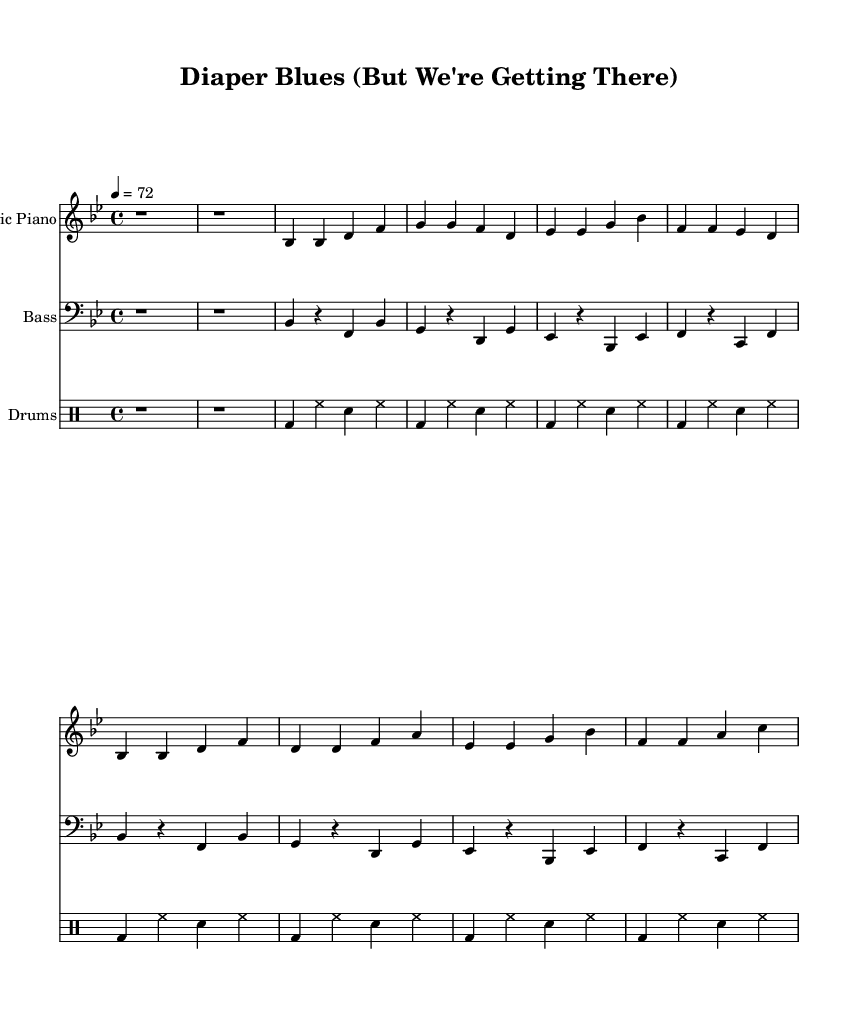What is the key signature of this music? The key signature is B flat major, as indicated by the two flats (B flat and E flat) at the beginning of the staff.
Answer: B flat major What is the time signature of this piece? The time signature is 4/4, which allows for four beats in each measure. This is a common time signature often used in funk music.
Answer: 4/4 What is the tempo marking for this piece? The tempo marking is 72 beats per minute, which is indicated at the start of the score. This tempo suggests a moderate, relaxed pace appropriate for a ballad.
Answer: 72 How many measures are in the chorus? The chorus consists of four measures, as evident from the notation and the number of lines in the lyric section marking the chorus lyrics.
Answer: Four What instruments are used in this score? The instruments used are Electric Piano, Bass, and Drums. Each instrument has its corresponding staff which clearly indicates the instrumental parts.
Answer: Electric Piano, Bass, Drums What is the theme of the lyrics in this piece? The theme revolves around parenting, highlighting both the joys and challenges, specifically focusing on potty training as a milestone in the child's growth.
Answer: Parenting, potty training 